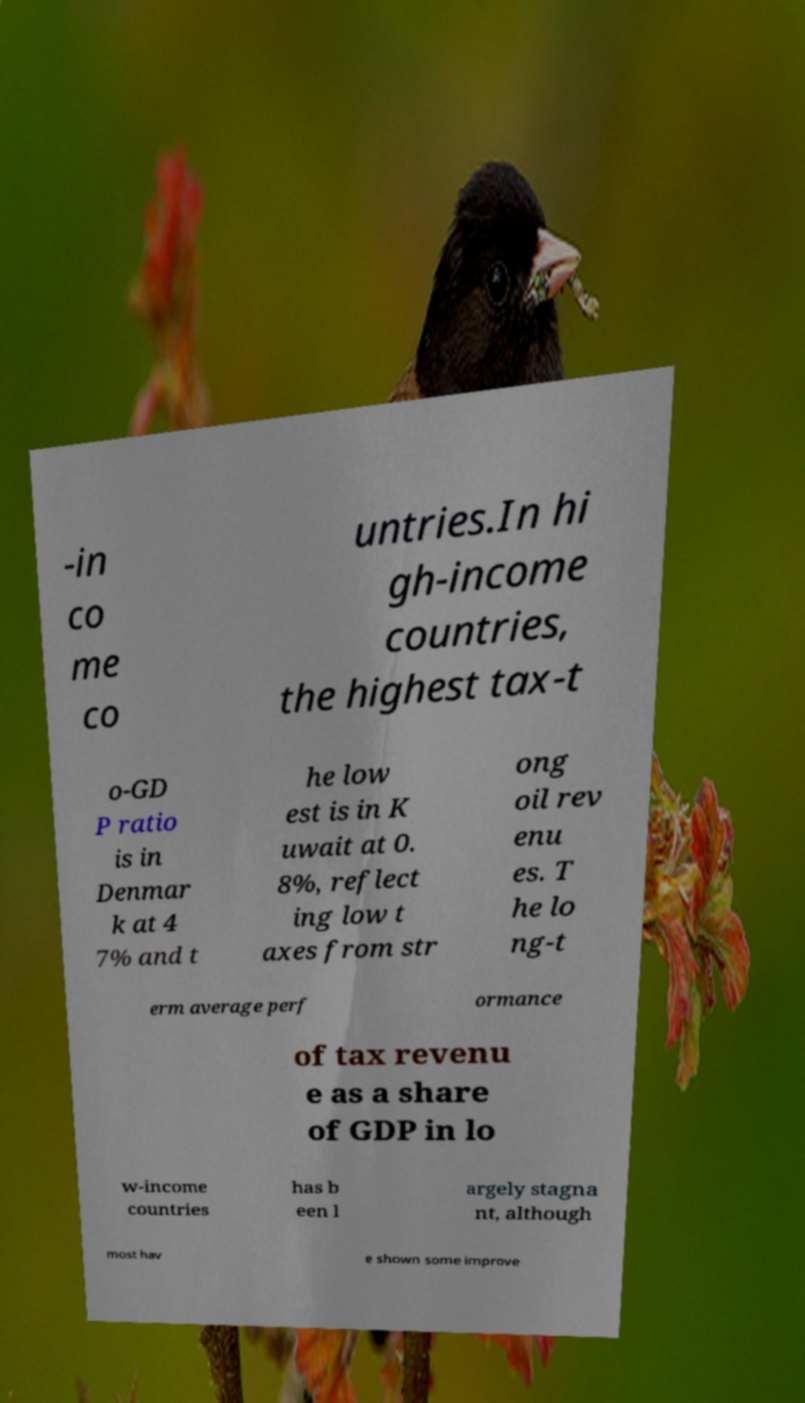I need the written content from this picture converted into text. Can you do that? -in co me co untries.In hi gh-income countries, the highest tax-t o-GD P ratio is in Denmar k at 4 7% and t he low est is in K uwait at 0. 8%, reflect ing low t axes from str ong oil rev enu es. T he lo ng-t erm average perf ormance of tax revenu e as a share of GDP in lo w-income countries has b een l argely stagna nt, although most hav e shown some improve 